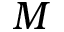<formula> <loc_0><loc_0><loc_500><loc_500>M</formula> 